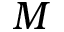<formula> <loc_0><loc_0><loc_500><loc_500>M</formula> 